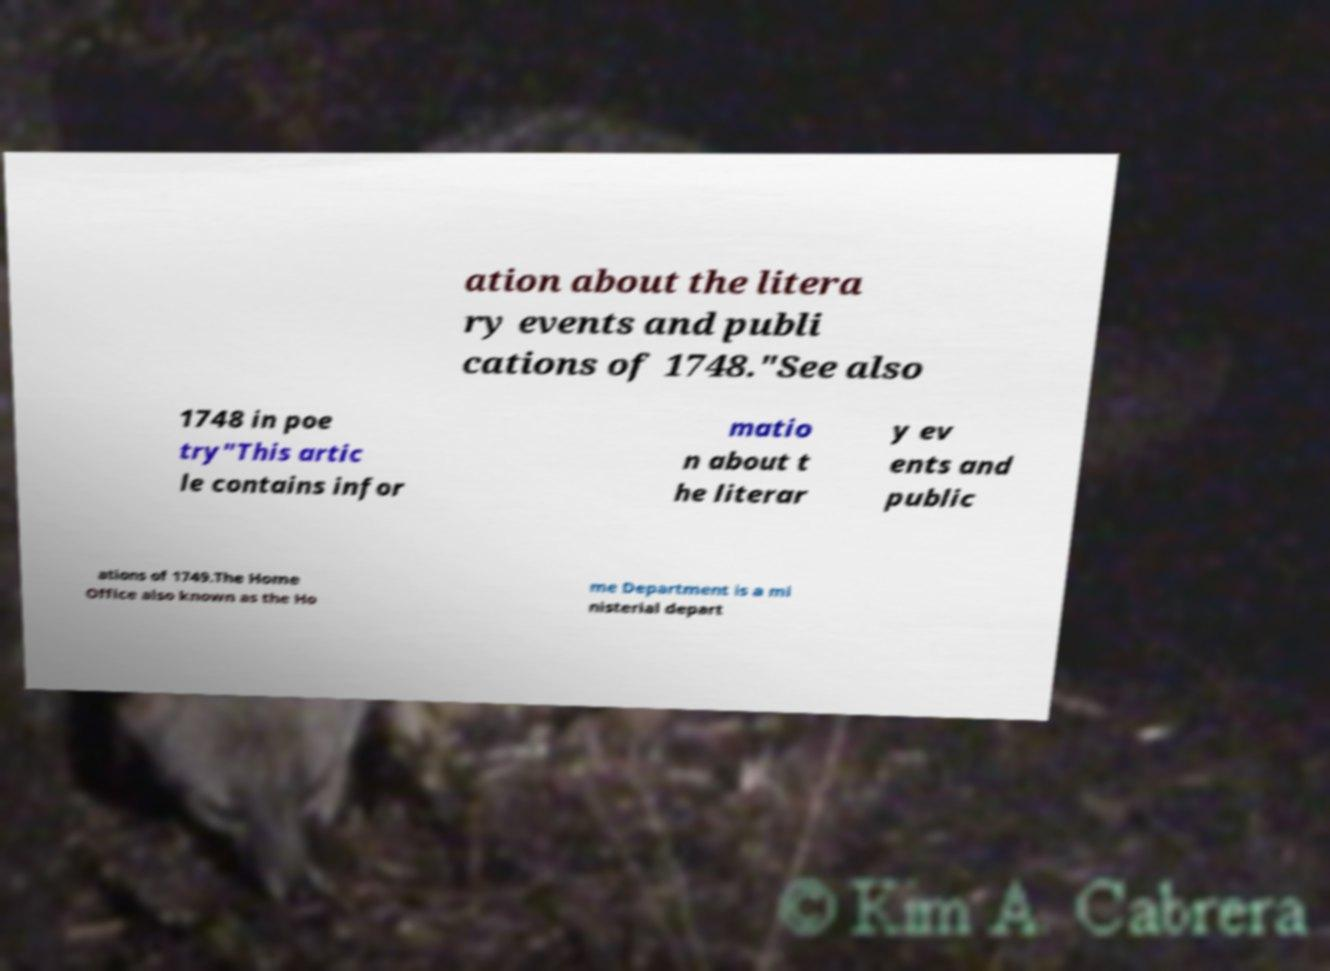What messages or text are displayed in this image? I need them in a readable, typed format. ation about the litera ry events and publi cations of 1748."See also 1748 in poe try"This artic le contains infor matio n about t he literar y ev ents and public ations of 1749.The Home Office also known as the Ho me Department is a mi nisterial depart 